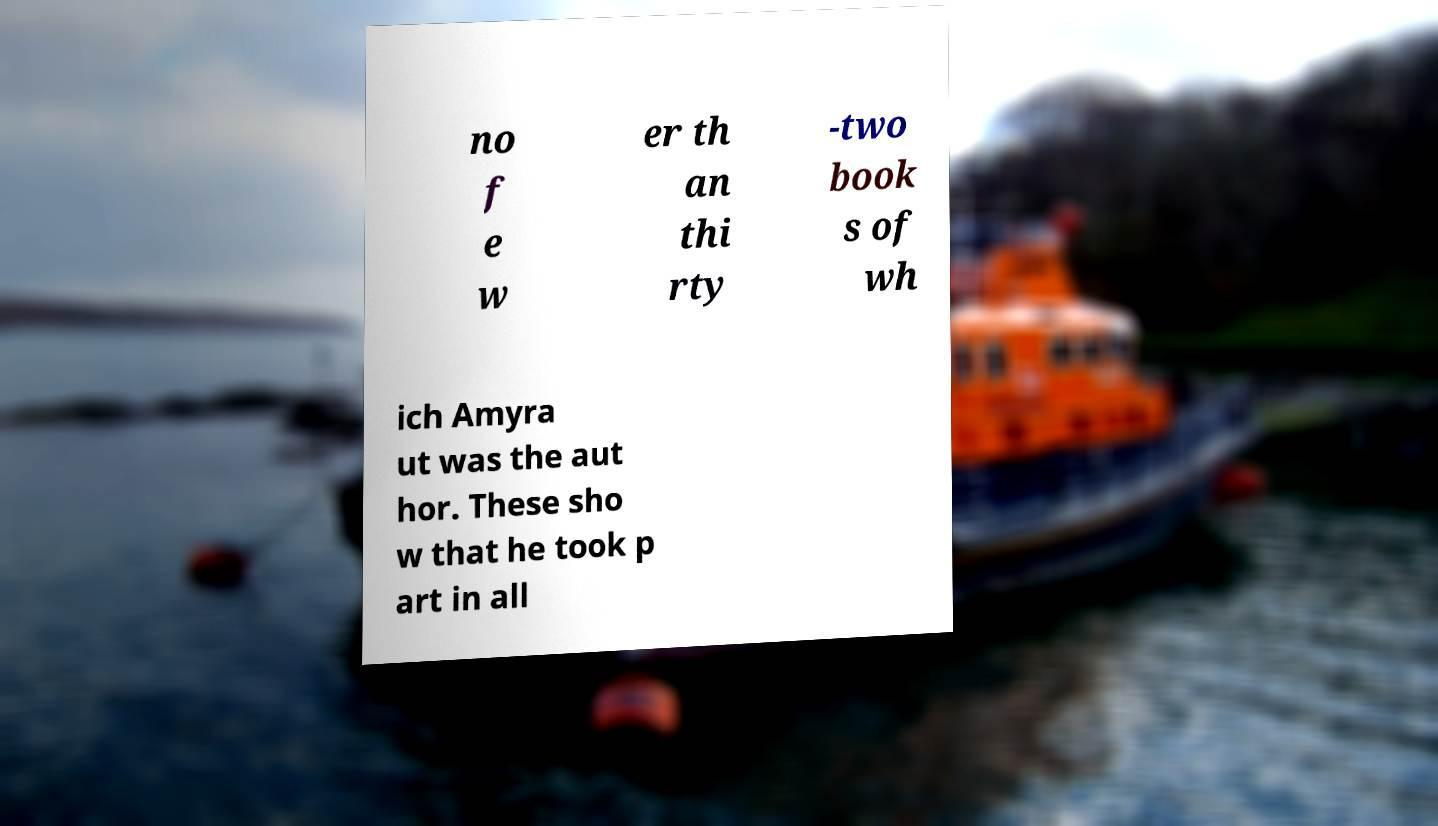What messages or text are displayed in this image? I need them in a readable, typed format. no f e w er th an thi rty -two book s of wh ich Amyra ut was the aut hor. These sho w that he took p art in all 